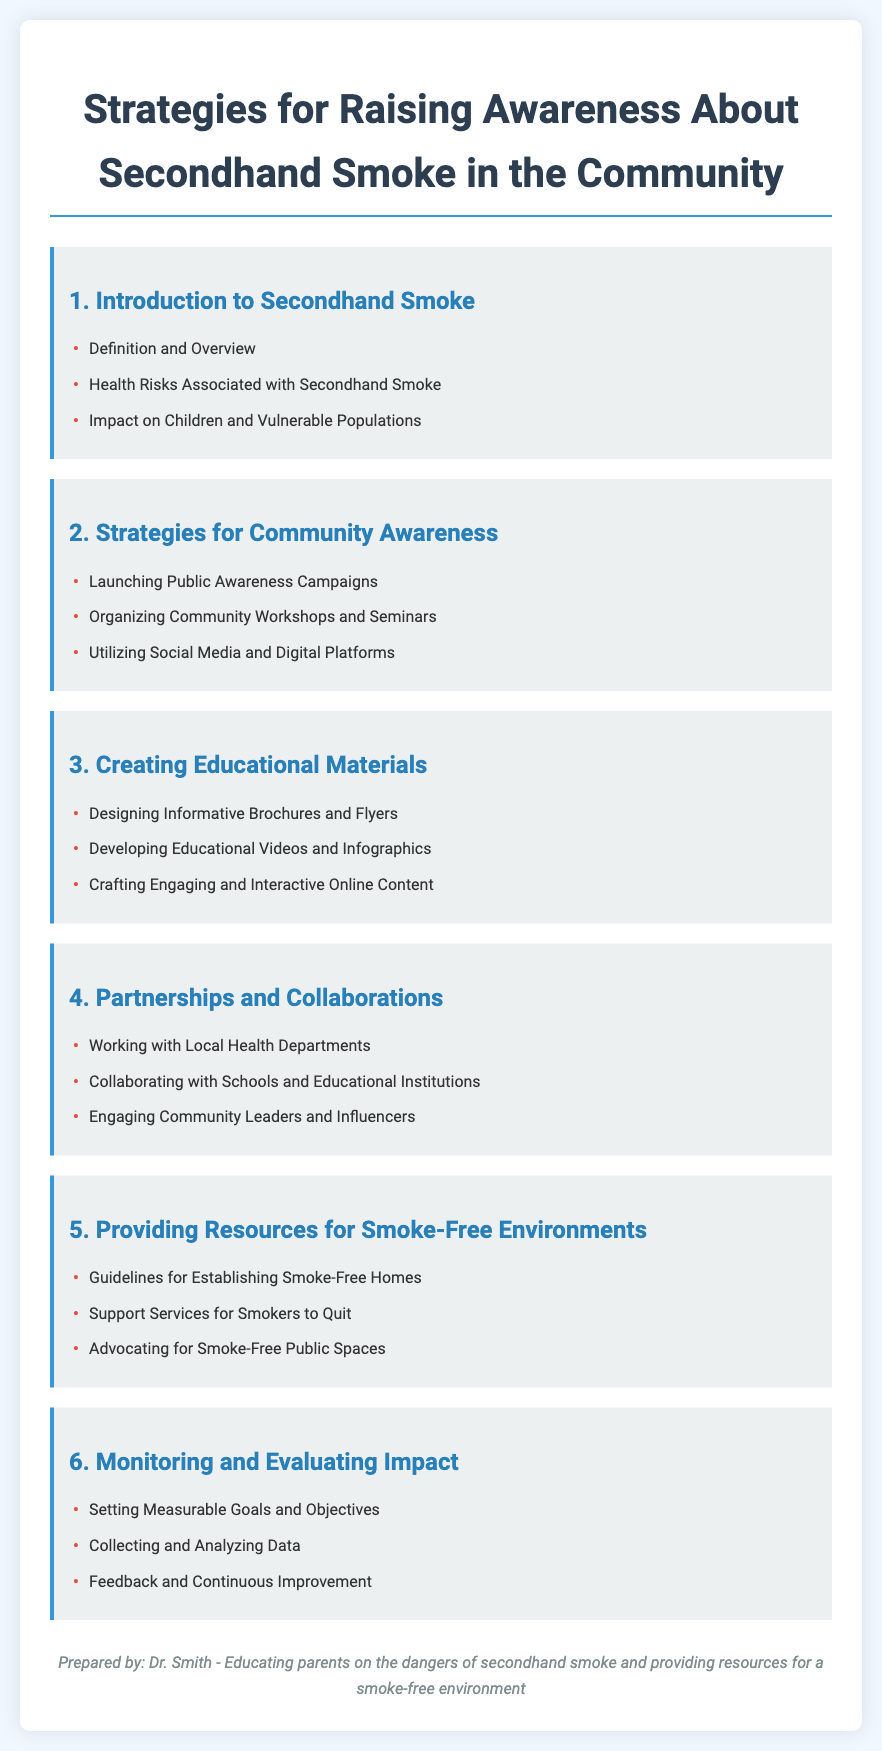What is the title of the document? The title of the document is stated at the top, which clearly identifies the focus of the content.
Answer: Strategies for Raising Awareness About Secondhand Smoke in the Community How many main sections are in the document? The document lists six main sections, each focusing on different strategies and aspects of secondhand smoke awareness.
Answer: 6 What type of materials does section 3 suggest creating? Section 3 emphasizes the development of various educational materials to inform the community about secondhand smoke.
Answer: Educational Materials Who prepared the document? The document credits the preparation of its content to an individual, which is included at the bottom of the rendered document.
Answer: Dr. Smith What is one strategy for community awareness mentioned in section 2? Section 2 lists multiple strategies, highlighting various approaches to raise awareness within the community.
Answer: Public Awareness Campaigns Which vulnerable population is affected by secondhand smoke mentioned in section 1? Section 1 outlines several groups that may be particularly at risk because of secondhand smoke exposure.
Answer: Children What is the main purpose of the document? The overall purpose of the document is to educate the community about the dangers of secondhand smoke and provide strategies for awareness.
Answer: Educating parents on the dangers of secondhand smoke What kind of partnerships does section 4 encourage? Section 4 discusses the importance of building connections with various organizations to enhance the impact of awareness activities.
Answer: Collaborating with Schools and Educational Institutions 